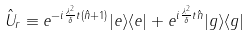Convert formula to latex. <formula><loc_0><loc_0><loc_500><loc_500>\hat { U } _ { r } \equiv e ^ { - i \frac { \lambda ^ { 2 } } { \delta } t ( \hat { n } + 1 ) } | e \rangle \langle e | + e ^ { i \frac { \lambda ^ { 2 } } { \delta } t \hat { n } } | g \rangle \langle g |</formula> 